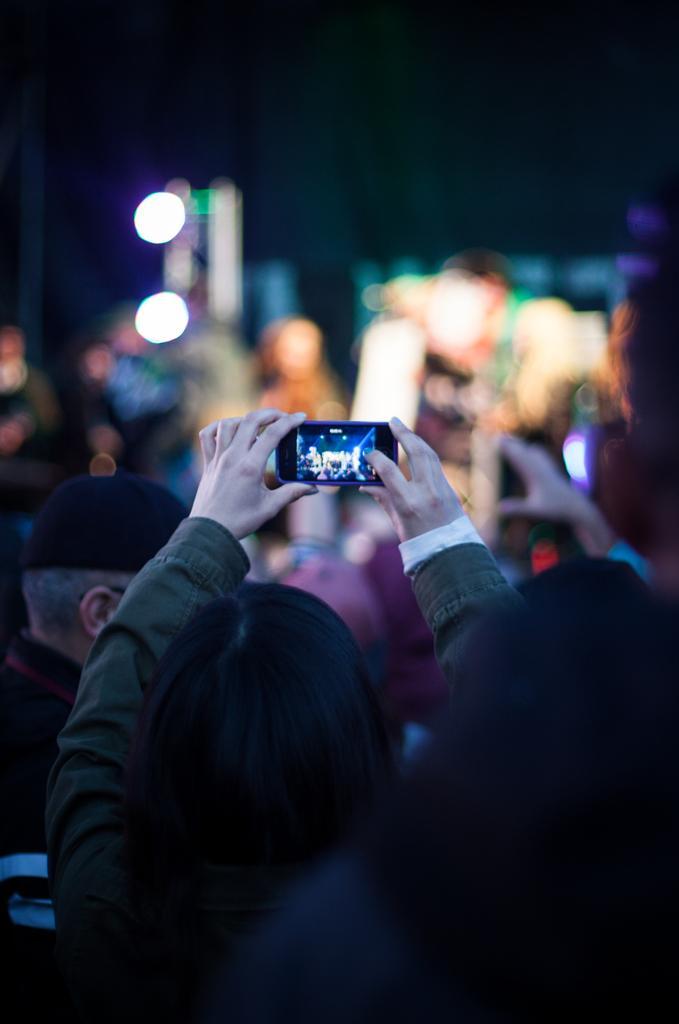Could you give a brief overview of what you see in this image? In this image there is a woman holding a mobile phone is clicking a picture, in front of the woman there is a person standing. 